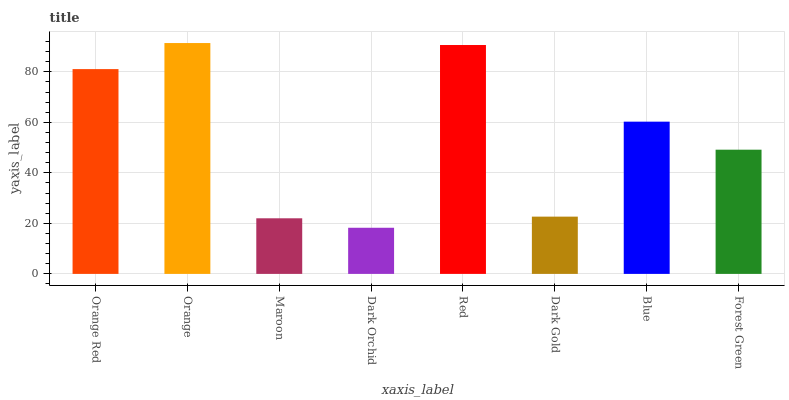Is Dark Orchid the minimum?
Answer yes or no. Yes. Is Orange the maximum?
Answer yes or no. Yes. Is Maroon the minimum?
Answer yes or no. No. Is Maroon the maximum?
Answer yes or no. No. Is Orange greater than Maroon?
Answer yes or no. Yes. Is Maroon less than Orange?
Answer yes or no. Yes. Is Maroon greater than Orange?
Answer yes or no. No. Is Orange less than Maroon?
Answer yes or no. No. Is Blue the high median?
Answer yes or no. Yes. Is Forest Green the low median?
Answer yes or no. Yes. Is Forest Green the high median?
Answer yes or no. No. Is Maroon the low median?
Answer yes or no. No. 